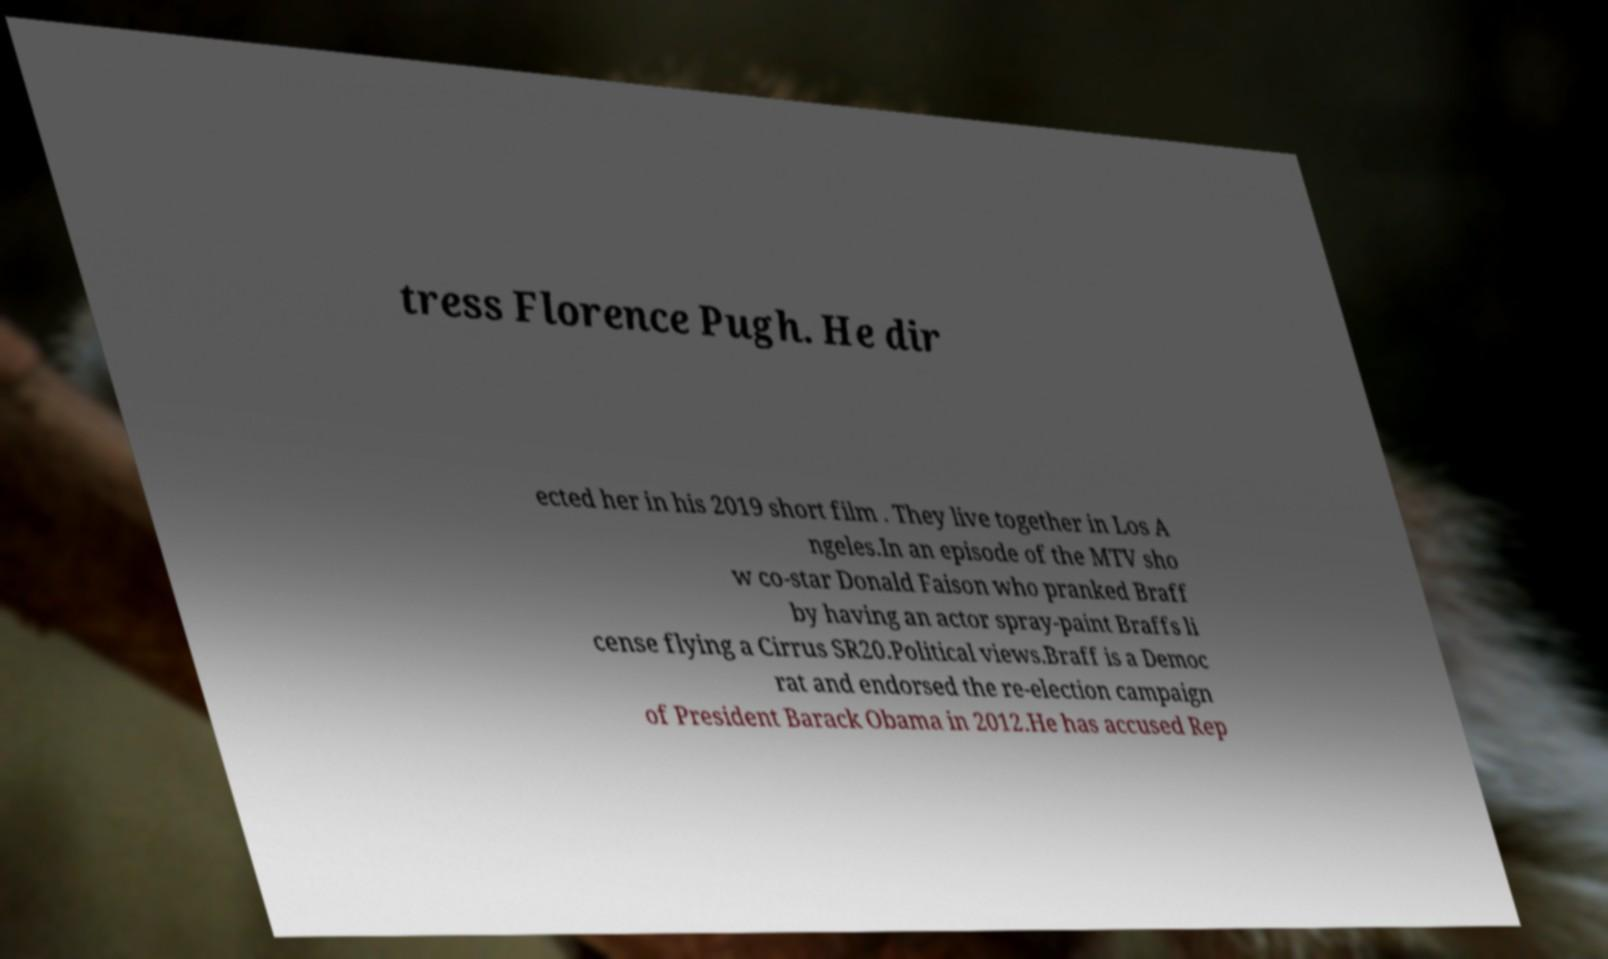What messages or text are displayed in this image? I need them in a readable, typed format. tress Florence Pugh. He dir ected her in his 2019 short film . They live together in Los A ngeles.In an episode of the MTV sho w co-star Donald Faison who pranked Braff by having an actor spray-paint Braffs li cense flying a Cirrus SR20.Political views.Braff is a Democ rat and endorsed the re-election campaign of President Barack Obama in 2012.He has accused Rep 